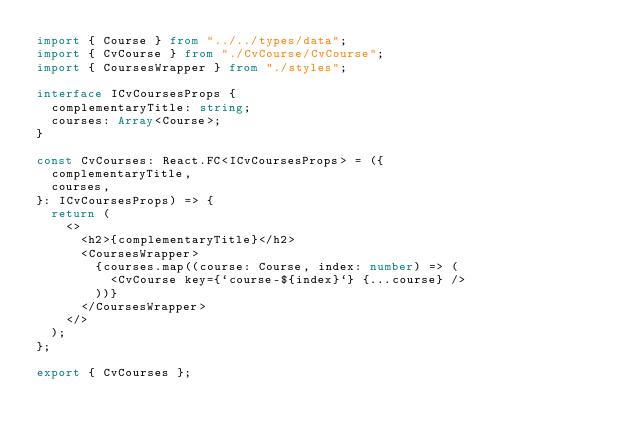Convert code to text. <code><loc_0><loc_0><loc_500><loc_500><_TypeScript_>import { Course } from "../../types/data";
import { CvCourse } from "./CvCourse/CvCourse";
import { CoursesWrapper } from "./styles";

interface ICvCoursesProps {
  complementaryTitle: string;
  courses: Array<Course>;
}

const CvCourses: React.FC<ICvCoursesProps> = ({
  complementaryTitle,
  courses,
}: ICvCoursesProps) => {
  return (
    <>
      <h2>{complementaryTitle}</h2>
      <CoursesWrapper>
        {courses.map((course: Course, index: number) => (
          <CvCourse key={`course-${index}`} {...course} />
        ))}
      </CoursesWrapper>
    </>
  );
};

export { CvCourses };
</code> 